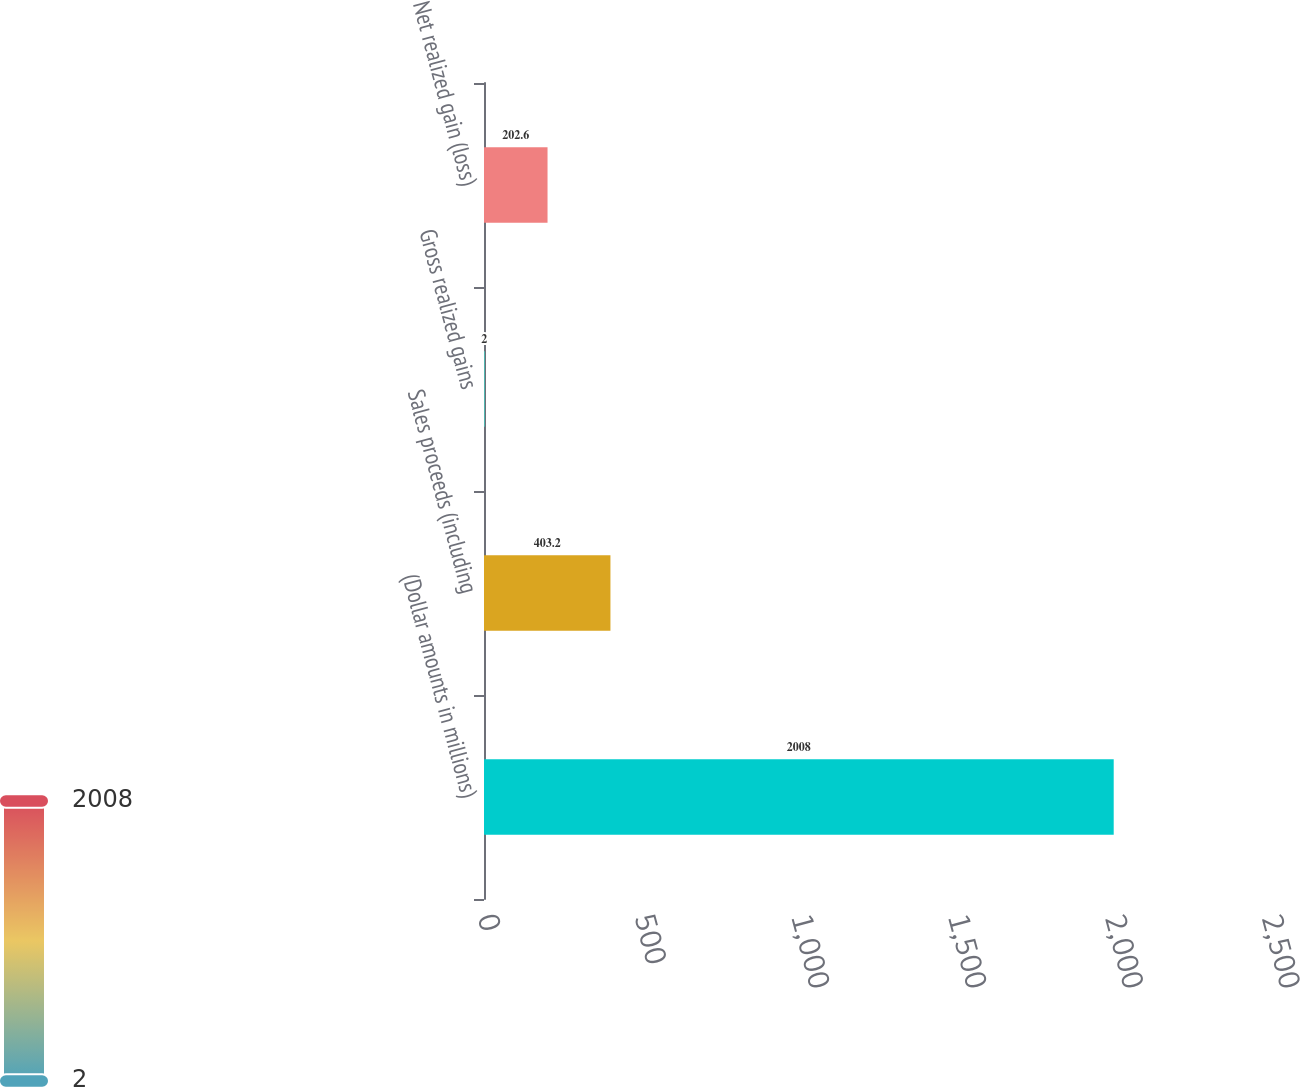<chart> <loc_0><loc_0><loc_500><loc_500><bar_chart><fcel>(Dollar amounts in millions)<fcel>Sales proceeds (including<fcel>Gross realized gains<fcel>Net realized gain (loss)<nl><fcel>2008<fcel>403.2<fcel>2<fcel>202.6<nl></chart> 